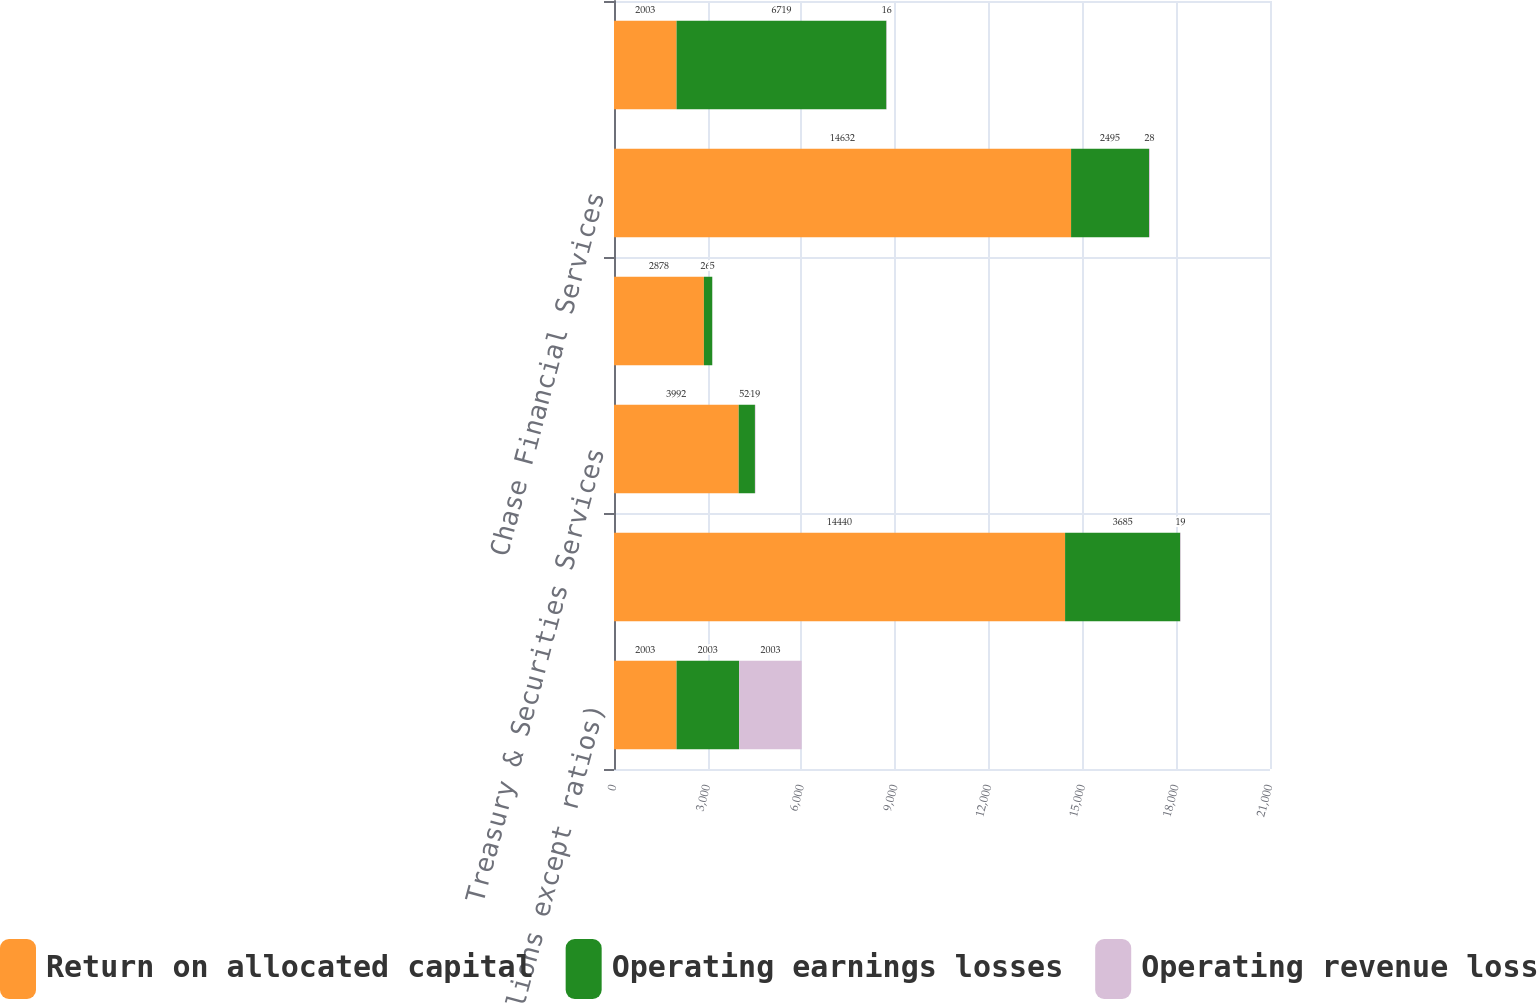Convert chart to OTSL. <chart><loc_0><loc_0><loc_500><loc_500><stacked_bar_chart><ecel><fcel>(in millions except ratios)<fcel>Investment Bank<fcel>Treasury & Securities Services<fcel>Investment Management &<fcel>Chase Financial Services<fcel>JPMorgan Chase<nl><fcel>Return on allocated capital<fcel>2003<fcel>14440<fcel>3992<fcel>2878<fcel>14632<fcel>2003<nl><fcel>Operating earnings losses<fcel>2003<fcel>3685<fcel>520<fcel>268<fcel>2495<fcel>6719<nl><fcel>Operating revenue loss<fcel>2003<fcel>19<fcel>19<fcel>5<fcel>28<fcel>16<nl></chart> 